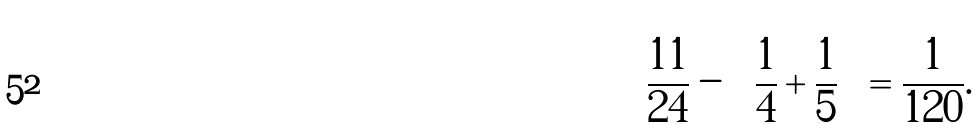Convert formula to latex. <formula><loc_0><loc_0><loc_500><loc_500>\frac { 1 1 } { 2 4 } - \left ( \frac { 1 } { 4 } + \frac { 1 } { 5 } \right ) = \frac { 1 } { 1 2 0 } .</formula> 